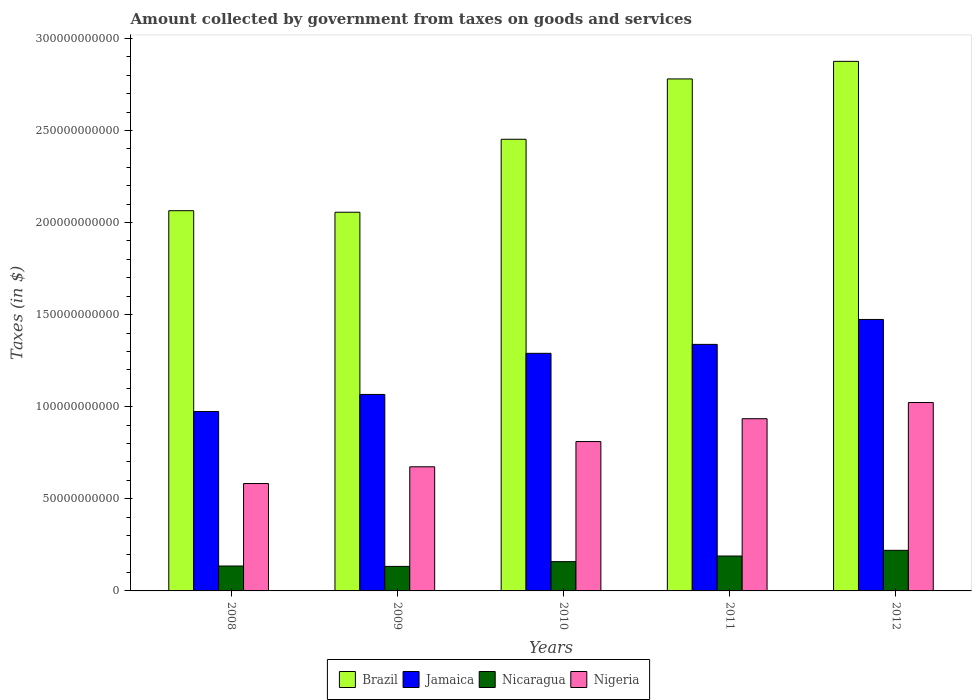How many different coloured bars are there?
Provide a short and direct response. 4. How many groups of bars are there?
Make the answer very short. 5. Are the number of bars per tick equal to the number of legend labels?
Ensure brevity in your answer.  Yes. Are the number of bars on each tick of the X-axis equal?
Ensure brevity in your answer.  Yes. How many bars are there on the 3rd tick from the right?
Offer a terse response. 4. What is the amount collected by government from taxes on goods and services in Nicaragua in 2012?
Your response must be concise. 2.20e+1. Across all years, what is the maximum amount collected by government from taxes on goods and services in Nicaragua?
Offer a terse response. 2.20e+1. Across all years, what is the minimum amount collected by government from taxes on goods and services in Nigeria?
Offer a very short reply. 5.83e+1. In which year was the amount collected by government from taxes on goods and services in Brazil maximum?
Offer a very short reply. 2012. In which year was the amount collected by government from taxes on goods and services in Nicaragua minimum?
Your response must be concise. 2009. What is the total amount collected by government from taxes on goods and services in Jamaica in the graph?
Your response must be concise. 6.14e+11. What is the difference between the amount collected by government from taxes on goods and services in Nicaragua in 2011 and that in 2012?
Keep it short and to the point. -3.09e+09. What is the difference between the amount collected by government from taxes on goods and services in Nigeria in 2011 and the amount collected by government from taxes on goods and services in Nicaragua in 2009?
Keep it short and to the point. 8.02e+1. What is the average amount collected by government from taxes on goods and services in Nicaragua per year?
Give a very brief answer. 1.67e+1. In the year 2008, what is the difference between the amount collected by government from taxes on goods and services in Nigeria and amount collected by government from taxes on goods and services in Brazil?
Keep it short and to the point. -1.48e+11. What is the ratio of the amount collected by government from taxes on goods and services in Nicaragua in 2008 to that in 2011?
Offer a terse response. 0.71. Is the amount collected by government from taxes on goods and services in Brazil in 2010 less than that in 2012?
Give a very brief answer. Yes. What is the difference between the highest and the second highest amount collected by government from taxes on goods and services in Brazil?
Provide a short and direct response. 9.55e+09. What is the difference between the highest and the lowest amount collected by government from taxes on goods and services in Nicaragua?
Provide a short and direct response. 8.72e+09. What does the 2nd bar from the left in 2012 represents?
Your response must be concise. Jamaica. What does the 3rd bar from the right in 2009 represents?
Offer a very short reply. Jamaica. Is it the case that in every year, the sum of the amount collected by government from taxes on goods and services in Jamaica and amount collected by government from taxes on goods and services in Brazil is greater than the amount collected by government from taxes on goods and services in Nigeria?
Your response must be concise. Yes. How many bars are there?
Keep it short and to the point. 20. Are all the bars in the graph horizontal?
Your response must be concise. No. How many years are there in the graph?
Provide a short and direct response. 5. Are the values on the major ticks of Y-axis written in scientific E-notation?
Your response must be concise. No. Does the graph contain grids?
Offer a terse response. No. How many legend labels are there?
Give a very brief answer. 4. What is the title of the graph?
Provide a succinct answer. Amount collected by government from taxes on goods and services. Does "Tonga" appear as one of the legend labels in the graph?
Offer a very short reply. No. What is the label or title of the X-axis?
Provide a short and direct response. Years. What is the label or title of the Y-axis?
Provide a succinct answer. Taxes (in $). What is the Taxes (in $) of Brazil in 2008?
Keep it short and to the point. 2.06e+11. What is the Taxes (in $) of Jamaica in 2008?
Your answer should be very brief. 9.74e+1. What is the Taxes (in $) in Nicaragua in 2008?
Offer a very short reply. 1.35e+1. What is the Taxes (in $) in Nigeria in 2008?
Offer a very short reply. 5.83e+1. What is the Taxes (in $) in Brazil in 2009?
Give a very brief answer. 2.06e+11. What is the Taxes (in $) of Jamaica in 2009?
Provide a short and direct response. 1.07e+11. What is the Taxes (in $) of Nicaragua in 2009?
Give a very brief answer. 1.33e+1. What is the Taxes (in $) in Nigeria in 2009?
Offer a very short reply. 6.74e+1. What is the Taxes (in $) in Brazil in 2010?
Your answer should be compact. 2.45e+11. What is the Taxes (in $) in Jamaica in 2010?
Ensure brevity in your answer.  1.29e+11. What is the Taxes (in $) of Nicaragua in 2010?
Offer a very short reply. 1.59e+1. What is the Taxes (in $) of Nigeria in 2010?
Your response must be concise. 8.11e+1. What is the Taxes (in $) of Brazil in 2011?
Offer a very short reply. 2.78e+11. What is the Taxes (in $) of Jamaica in 2011?
Your answer should be very brief. 1.34e+11. What is the Taxes (in $) in Nicaragua in 2011?
Make the answer very short. 1.89e+1. What is the Taxes (in $) of Nigeria in 2011?
Offer a very short reply. 9.35e+1. What is the Taxes (in $) in Brazil in 2012?
Offer a very short reply. 2.88e+11. What is the Taxes (in $) in Jamaica in 2012?
Offer a terse response. 1.47e+11. What is the Taxes (in $) of Nicaragua in 2012?
Ensure brevity in your answer.  2.20e+1. What is the Taxes (in $) of Nigeria in 2012?
Ensure brevity in your answer.  1.02e+11. Across all years, what is the maximum Taxes (in $) in Brazil?
Offer a very short reply. 2.88e+11. Across all years, what is the maximum Taxes (in $) in Jamaica?
Make the answer very short. 1.47e+11. Across all years, what is the maximum Taxes (in $) in Nicaragua?
Offer a very short reply. 2.20e+1. Across all years, what is the maximum Taxes (in $) of Nigeria?
Provide a succinct answer. 1.02e+11. Across all years, what is the minimum Taxes (in $) in Brazil?
Give a very brief answer. 2.06e+11. Across all years, what is the minimum Taxes (in $) of Jamaica?
Give a very brief answer. 9.74e+1. Across all years, what is the minimum Taxes (in $) in Nicaragua?
Your answer should be very brief. 1.33e+1. Across all years, what is the minimum Taxes (in $) of Nigeria?
Give a very brief answer. 5.83e+1. What is the total Taxes (in $) of Brazil in the graph?
Provide a short and direct response. 1.22e+12. What is the total Taxes (in $) of Jamaica in the graph?
Ensure brevity in your answer.  6.14e+11. What is the total Taxes (in $) in Nicaragua in the graph?
Ensure brevity in your answer.  8.37e+1. What is the total Taxes (in $) in Nigeria in the graph?
Provide a short and direct response. 4.03e+11. What is the difference between the Taxes (in $) of Brazil in 2008 and that in 2009?
Ensure brevity in your answer.  8.35e+08. What is the difference between the Taxes (in $) of Jamaica in 2008 and that in 2009?
Offer a terse response. -9.27e+09. What is the difference between the Taxes (in $) in Nicaragua in 2008 and that in 2009?
Give a very brief answer. 2.08e+08. What is the difference between the Taxes (in $) in Nigeria in 2008 and that in 2009?
Provide a short and direct response. -9.10e+09. What is the difference between the Taxes (in $) in Brazil in 2008 and that in 2010?
Make the answer very short. -3.88e+1. What is the difference between the Taxes (in $) in Jamaica in 2008 and that in 2010?
Offer a very short reply. -3.16e+1. What is the difference between the Taxes (in $) of Nicaragua in 2008 and that in 2010?
Ensure brevity in your answer.  -2.37e+09. What is the difference between the Taxes (in $) in Nigeria in 2008 and that in 2010?
Your response must be concise. -2.28e+1. What is the difference between the Taxes (in $) in Brazil in 2008 and that in 2011?
Offer a terse response. -7.15e+1. What is the difference between the Taxes (in $) in Jamaica in 2008 and that in 2011?
Offer a very short reply. -3.64e+1. What is the difference between the Taxes (in $) in Nicaragua in 2008 and that in 2011?
Offer a terse response. -5.42e+09. What is the difference between the Taxes (in $) in Nigeria in 2008 and that in 2011?
Provide a short and direct response. -3.52e+1. What is the difference between the Taxes (in $) in Brazil in 2008 and that in 2012?
Your response must be concise. -8.11e+1. What is the difference between the Taxes (in $) of Jamaica in 2008 and that in 2012?
Your response must be concise. -5.00e+1. What is the difference between the Taxes (in $) of Nicaragua in 2008 and that in 2012?
Offer a very short reply. -8.51e+09. What is the difference between the Taxes (in $) in Nigeria in 2008 and that in 2012?
Your answer should be very brief. -4.40e+1. What is the difference between the Taxes (in $) in Brazil in 2009 and that in 2010?
Provide a succinct answer. -3.96e+1. What is the difference between the Taxes (in $) in Jamaica in 2009 and that in 2010?
Ensure brevity in your answer.  -2.23e+1. What is the difference between the Taxes (in $) in Nicaragua in 2009 and that in 2010?
Give a very brief answer. -2.58e+09. What is the difference between the Taxes (in $) of Nigeria in 2009 and that in 2010?
Offer a terse response. -1.37e+1. What is the difference between the Taxes (in $) in Brazil in 2009 and that in 2011?
Your response must be concise. -7.24e+1. What is the difference between the Taxes (in $) in Jamaica in 2009 and that in 2011?
Your answer should be compact. -2.72e+1. What is the difference between the Taxes (in $) of Nicaragua in 2009 and that in 2011?
Your response must be concise. -5.63e+09. What is the difference between the Taxes (in $) in Nigeria in 2009 and that in 2011?
Keep it short and to the point. -2.61e+1. What is the difference between the Taxes (in $) in Brazil in 2009 and that in 2012?
Ensure brevity in your answer.  -8.19e+1. What is the difference between the Taxes (in $) of Jamaica in 2009 and that in 2012?
Keep it short and to the point. -4.07e+1. What is the difference between the Taxes (in $) of Nicaragua in 2009 and that in 2012?
Offer a very short reply. -8.72e+09. What is the difference between the Taxes (in $) in Nigeria in 2009 and that in 2012?
Offer a terse response. -3.49e+1. What is the difference between the Taxes (in $) in Brazil in 2010 and that in 2011?
Provide a short and direct response. -3.28e+1. What is the difference between the Taxes (in $) of Jamaica in 2010 and that in 2011?
Your response must be concise. -4.85e+09. What is the difference between the Taxes (in $) in Nicaragua in 2010 and that in 2011?
Provide a succinct answer. -3.05e+09. What is the difference between the Taxes (in $) in Nigeria in 2010 and that in 2011?
Provide a short and direct response. -1.24e+1. What is the difference between the Taxes (in $) of Brazil in 2010 and that in 2012?
Give a very brief answer. -4.23e+1. What is the difference between the Taxes (in $) in Jamaica in 2010 and that in 2012?
Offer a very short reply. -1.84e+1. What is the difference between the Taxes (in $) of Nicaragua in 2010 and that in 2012?
Ensure brevity in your answer.  -6.14e+09. What is the difference between the Taxes (in $) in Nigeria in 2010 and that in 2012?
Provide a succinct answer. -2.12e+1. What is the difference between the Taxes (in $) of Brazil in 2011 and that in 2012?
Your response must be concise. -9.55e+09. What is the difference between the Taxes (in $) in Jamaica in 2011 and that in 2012?
Give a very brief answer. -1.35e+1. What is the difference between the Taxes (in $) of Nicaragua in 2011 and that in 2012?
Give a very brief answer. -3.09e+09. What is the difference between the Taxes (in $) in Nigeria in 2011 and that in 2012?
Provide a short and direct response. -8.80e+09. What is the difference between the Taxes (in $) in Brazil in 2008 and the Taxes (in $) in Jamaica in 2009?
Make the answer very short. 9.98e+1. What is the difference between the Taxes (in $) of Brazil in 2008 and the Taxes (in $) of Nicaragua in 2009?
Give a very brief answer. 1.93e+11. What is the difference between the Taxes (in $) in Brazil in 2008 and the Taxes (in $) in Nigeria in 2009?
Offer a very short reply. 1.39e+11. What is the difference between the Taxes (in $) in Jamaica in 2008 and the Taxes (in $) in Nicaragua in 2009?
Ensure brevity in your answer.  8.41e+1. What is the difference between the Taxes (in $) of Jamaica in 2008 and the Taxes (in $) of Nigeria in 2009?
Offer a terse response. 3.00e+1. What is the difference between the Taxes (in $) in Nicaragua in 2008 and the Taxes (in $) in Nigeria in 2009?
Provide a succinct answer. -5.39e+1. What is the difference between the Taxes (in $) in Brazil in 2008 and the Taxes (in $) in Jamaica in 2010?
Offer a terse response. 7.74e+1. What is the difference between the Taxes (in $) of Brazil in 2008 and the Taxes (in $) of Nicaragua in 2010?
Make the answer very short. 1.91e+11. What is the difference between the Taxes (in $) in Brazil in 2008 and the Taxes (in $) in Nigeria in 2010?
Offer a very short reply. 1.25e+11. What is the difference between the Taxes (in $) in Jamaica in 2008 and the Taxes (in $) in Nicaragua in 2010?
Your answer should be compact. 8.15e+1. What is the difference between the Taxes (in $) of Jamaica in 2008 and the Taxes (in $) of Nigeria in 2010?
Provide a succinct answer. 1.63e+1. What is the difference between the Taxes (in $) of Nicaragua in 2008 and the Taxes (in $) of Nigeria in 2010?
Your answer should be compact. -6.76e+1. What is the difference between the Taxes (in $) of Brazil in 2008 and the Taxes (in $) of Jamaica in 2011?
Your answer should be very brief. 7.26e+1. What is the difference between the Taxes (in $) in Brazil in 2008 and the Taxes (in $) in Nicaragua in 2011?
Provide a succinct answer. 1.87e+11. What is the difference between the Taxes (in $) in Brazil in 2008 and the Taxes (in $) in Nigeria in 2011?
Provide a succinct answer. 1.13e+11. What is the difference between the Taxes (in $) of Jamaica in 2008 and the Taxes (in $) of Nicaragua in 2011?
Your answer should be very brief. 7.85e+1. What is the difference between the Taxes (in $) of Jamaica in 2008 and the Taxes (in $) of Nigeria in 2011?
Your answer should be very brief. 3.91e+09. What is the difference between the Taxes (in $) of Nicaragua in 2008 and the Taxes (in $) of Nigeria in 2011?
Keep it short and to the point. -8.00e+1. What is the difference between the Taxes (in $) of Brazil in 2008 and the Taxes (in $) of Jamaica in 2012?
Provide a succinct answer. 5.91e+1. What is the difference between the Taxes (in $) of Brazil in 2008 and the Taxes (in $) of Nicaragua in 2012?
Provide a succinct answer. 1.84e+11. What is the difference between the Taxes (in $) in Brazil in 2008 and the Taxes (in $) in Nigeria in 2012?
Make the answer very short. 1.04e+11. What is the difference between the Taxes (in $) of Jamaica in 2008 and the Taxes (in $) of Nicaragua in 2012?
Your response must be concise. 7.54e+1. What is the difference between the Taxes (in $) in Jamaica in 2008 and the Taxes (in $) in Nigeria in 2012?
Offer a terse response. -4.89e+09. What is the difference between the Taxes (in $) in Nicaragua in 2008 and the Taxes (in $) in Nigeria in 2012?
Provide a succinct answer. -8.88e+1. What is the difference between the Taxes (in $) in Brazil in 2009 and the Taxes (in $) in Jamaica in 2010?
Provide a succinct answer. 7.66e+1. What is the difference between the Taxes (in $) of Brazil in 2009 and the Taxes (in $) of Nicaragua in 2010?
Offer a very short reply. 1.90e+11. What is the difference between the Taxes (in $) of Brazil in 2009 and the Taxes (in $) of Nigeria in 2010?
Give a very brief answer. 1.25e+11. What is the difference between the Taxes (in $) of Jamaica in 2009 and the Taxes (in $) of Nicaragua in 2010?
Provide a short and direct response. 9.08e+1. What is the difference between the Taxes (in $) of Jamaica in 2009 and the Taxes (in $) of Nigeria in 2010?
Provide a succinct answer. 2.56e+1. What is the difference between the Taxes (in $) in Nicaragua in 2009 and the Taxes (in $) in Nigeria in 2010?
Give a very brief answer. -6.78e+1. What is the difference between the Taxes (in $) in Brazil in 2009 and the Taxes (in $) in Jamaica in 2011?
Your answer should be very brief. 7.17e+1. What is the difference between the Taxes (in $) of Brazil in 2009 and the Taxes (in $) of Nicaragua in 2011?
Offer a terse response. 1.87e+11. What is the difference between the Taxes (in $) in Brazil in 2009 and the Taxes (in $) in Nigeria in 2011?
Your answer should be very brief. 1.12e+11. What is the difference between the Taxes (in $) in Jamaica in 2009 and the Taxes (in $) in Nicaragua in 2011?
Make the answer very short. 8.77e+1. What is the difference between the Taxes (in $) in Jamaica in 2009 and the Taxes (in $) in Nigeria in 2011?
Offer a terse response. 1.32e+1. What is the difference between the Taxes (in $) in Nicaragua in 2009 and the Taxes (in $) in Nigeria in 2011?
Your answer should be compact. -8.02e+1. What is the difference between the Taxes (in $) of Brazil in 2009 and the Taxes (in $) of Jamaica in 2012?
Ensure brevity in your answer.  5.82e+1. What is the difference between the Taxes (in $) of Brazil in 2009 and the Taxes (in $) of Nicaragua in 2012?
Provide a short and direct response. 1.84e+11. What is the difference between the Taxes (in $) in Brazil in 2009 and the Taxes (in $) in Nigeria in 2012?
Give a very brief answer. 1.03e+11. What is the difference between the Taxes (in $) of Jamaica in 2009 and the Taxes (in $) of Nicaragua in 2012?
Your answer should be compact. 8.46e+1. What is the difference between the Taxes (in $) in Jamaica in 2009 and the Taxes (in $) in Nigeria in 2012?
Keep it short and to the point. 4.38e+09. What is the difference between the Taxes (in $) in Nicaragua in 2009 and the Taxes (in $) in Nigeria in 2012?
Give a very brief answer. -8.90e+1. What is the difference between the Taxes (in $) of Brazil in 2010 and the Taxes (in $) of Jamaica in 2011?
Make the answer very short. 1.11e+11. What is the difference between the Taxes (in $) in Brazil in 2010 and the Taxes (in $) in Nicaragua in 2011?
Provide a succinct answer. 2.26e+11. What is the difference between the Taxes (in $) of Brazil in 2010 and the Taxes (in $) of Nigeria in 2011?
Your answer should be very brief. 1.52e+11. What is the difference between the Taxes (in $) in Jamaica in 2010 and the Taxes (in $) in Nicaragua in 2011?
Make the answer very short. 1.10e+11. What is the difference between the Taxes (in $) of Jamaica in 2010 and the Taxes (in $) of Nigeria in 2011?
Provide a short and direct response. 3.55e+1. What is the difference between the Taxes (in $) of Nicaragua in 2010 and the Taxes (in $) of Nigeria in 2011?
Make the answer very short. -7.76e+1. What is the difference between the Taxes (in $) in Brazil in 2010 and the Taxes (in $) in Jamaica in 2012?
Your answer should be very brief. 9.78e+1. What is the difference between the Taxes (in $) of Brazil in 2010 and the Taxes (in $) of Nicaragua in 2012?
Your response must be concise. 2.23e+11. What is the difference between the Taxes (in $) of Brazil in 2010 and the Taxes (in $) of Nigeria in 2012?
Offer a terse response. 1.43e+11. What is the difference between the Taxes (in $) in Jamaica in 2010 and the Taxes (in $) in Nicaragua in 2012?
Provide a succinct answer. 1.07e+11. What is the difference between the Taxes (in $) of Jamaica in 2010 and the Taxes (in $) of Nigeria in 2012?
Offer a terse response. 2.67e+1. What is the difference between the Taxes (in $) in Nicaragua in 2010 and the Taxes (in $) in Nigeria in 2012?
Give a very brief answer. -8.64e+1. What is the difference between the Taxes (in $) of Brazil in 2011 and the Taxes (in $) of Jamaica in 2012?
Your response must be concise. 1.31e+11. What is the difference between the Taxes (in $) in Brazil in 2011 and the Taxes (in $) in Nicaragua in 2012?
Your answer should be very brief. 2.56e+11. What is the difference between the Taxes (in $) of Brazil in 2011 and the Taxes (in $) of Nigeria in 2012?
Offer a very short reply. 1.76e+11. What is the difference between the Taxes (in $) of Jamaica in 2011 and the Taxes (in $) of Nicaragua in 2012?
Offer a terse response. 1.12e+11. What is the difference between the Taxes (in $) of Jamaica in 2011 and the Taxes (in $) of Nigeria in 2012?
Make the answer very short. 3.16e+1. What is the difference between the Taxes (in $) in Nicaragua in 2011 and the Taxes (in $) in Nigeria in 2012?
Ensure brevity in your answer.  -8.34e+1. What is the average Taxes (in $) in Brazil per year?
Offer a terse response. 2.45e+11. What is the average Taxes (in $) in Jamaica per year?
Your answer should be compact. 1.23e+11. What is the average Taxes (in $) in Nicaragua per year?
Offer a terse response. 1.67e+1. What is the average Taxes (in $) in Nigeria per year?
Make the answer very short. 8.05e+1. In the year 2008, what is the difference between the Taxes (in $) in Brazil and Taxes (in $) in Jamaica?
Your answer should be very brief. 1.09e+11. In the year 2008, what is the difference between the Taxes (in $) of Brazil and Taxes (in $) of Nicaragua?
Give a very brief answer. 1.93e+11. In the year 2008, what is the difference between the Taxes (in $) of Brazil and Taxes (in $) of Nigeria?
Offer a very short reply. 1.48e+11. In the year 2008, what is the difference between the Taxes (in $) in Jamaica and Taxes (in $) in Nicaragua?
Give a very brief answer. 8.39e+1. In the year 2008, what is the difference between the Taxes (in $) of Jamaica and Taxes (in $) of Nigeria?
Offer a terse response. 3.91e+1. In the year 2008, what is the difference between the Taxes (in $) of Nicaragua and Taxes (in $) of Nigeria?
Give a very brief answer. -4.48e+1. In the year 2009, what is the difference between the Taxes (in $) of Brazil and Taxes (in $) of Jamaica?
Provide a succinct answer. 9.89e+1. In the year 2009, what is the difference between the Taxes (in $) of Brazil and Taxes (in $) of Nicaragua?
Provide a short and direct response. 1.92e+11. In the year 2009, what is the difference between the Taxes (in $) in Brazil and Taxes (in $) in Nigeria?
Provide a succinct answer. 1.38e+11. In the year 2009, what is the difference between the Taxes (in $) of Jamaica and Taxes (in $) of Nicaragua?
Provide a short and direct response. 9.34e+1. In the year 2009, what is the difference between the Taxes (in $) in Jamaica and Taxes (in $) in Nigeria?
Your answer should be very brief. 3.93e+1. In the year 2009, what is the difference between the Taxes (in $) of Nicaragua and Taxes (in $) of Nigeria?
Offer a very short reply. -5.41e+1. In the year 2010, what is the difference between the Taxes (in $) in Brazil and Taxes (in $) in Jamaica?
Your response must be concise. 1.16e+11. In the year 2010, what is the difference between the Taxes (in $) in Brazil and Taxes (in $) in Nicaragua?
Provide a succinct answer. 2.29e+11. In the year 2010, what is the difference between the Taxes (in $) of Brazil and Taxes (in $) of Nigeria?
Offer a very short reply. 1.64e+11. In the year 2010, what is the difference between the Taxes (in $) of Jamaica and Taxes (in $) of Nicaragua?
Keep it short and to the point. 1.13e+11. In the year 2010, what is the difference between the Taxes (in $) of Jamaica and Taxes (in $) of Nigeria?
Offer a terse response. 4.79e+1. In the year 2010, what is the difference between the Taxes (in $) in Nicaragua and Taxes (in $) in Nigeria?
Provide a short and direct response. -6.52e+1. In the year 2011, what is the difference between the Taxes (in $) of Brazil and Taxes (in $) of Jamaica?
Offer a terse response. 1.44e+11. In the year 2011, what is the difference between the Taxes (in $) in Brazil and Taxes (in $) in Nicaragua?
Your answer should be compact. 2.59e+11. In the year 2011, what is the difference between the Taxes (in $) of Brazil and Taxes (in $) of Nigeria?
Your answer should be very brief. 1.84e+11. In the year 2011, what is the difference between the Taxes (in $) in Jamaica and Taxes (in $) in Nicaragua?
Your answer should be very brief. 1.15e+11. In the year 2011, what is the difference between the Taxes (in $) of Jamaica and Taxes (in $) of Nigeria?
Keep it short and to the point. 4.04e+1. In the year 2011, what is the difference between the Taxes (in $) in Nicaragua and Taxes (in $) in Nigeria?
Your response must be concise. -7.46e+1. In the year 2012, what is the difference between the Taxes (in $) of Brazil and Taxes (in $) of Jamaica?
Give a very brief answer. 1.40e+11. In the year 2012, what is the difference between the Taxes (in $) in Brazil and Taxes (in $) in Nicaragua?
Your response must be concise. 2.65e+11. In the year 2012, what is the difference between the Taxes (in $) in Brazil and Taxes (in $) in Nigeria?
Provide a short and direct response. 1.85e+11. In the year 2012, what is the difference between the Taxes (in $) in Jamaica and Taxes (in $) in Nicaragua?
Your response must be concise. 1.25e+11. In the year 2012, what is the difference between the Taxes (in $) in Jamaica and Taxes (in $) in Nigeria?
Offer a terse response. 4.51e+1. In the year 2012, what is the difference between the Taxes (in $) in Nicaragua and Taxes (in $) in Nigeria?
Make the answer very short. -8.03e+1. What is the ratio of the Taxes (in $) in Brazil in 2008 to that in 2009?
Ensure brevity in your answer.  1. What is the ratio of the Taxes (in $) in Jamaica in 2008 to that in 2009?
Offer a terse response. 0.91. What is the ratio of the Taxes (in $) of Nicaragua in 2008 to that in 2009?
Your answer should be compact. 1.02. What is the ratio of the Taxes (in $) of Nigeria in 2008 to that in 2009?
Offer a terse response. 0.86. What is the ratio of the Taxes (in $) of Brazil in 2008 to that in 2010?
Ensure brevity in your answer.  0.84. What is the ratio of the Taxes (in $) in Jamaica in 2008 to that in 2010?
Keep it short and to the point. 0.76. What is the ratio of the Taxes (in $) in Nicaragua in 2008 to that in 2010?
Your answer should be very brief. 0.85. What is the ratio of the Taxes (in $) of Nigeria in 2008 to that in 2010?
Make the answer very short. 0.72. What is the ratio of the Taxes (in $) in Brazil in 2008 to that in 2011?
Offer a very short reply. 0.74. What is the ratio of the Taxes (in $) of Jamaica in 2008 to that in 2011?
Keep it short and to the point. 0.73. What is the ratio of the Taxes (in $) of Nicaragua in 2008 to that in 2011?
Make the answer very short. 0.71. What is the ratio of the Taxes (in $) of Nigeria in 2008 to that in 2011?
Offer a very short reply. 0.62. What is the ratio of the Taxes (in $) in Brazil in 2008 to that in 2012?
Ensure brevity in your answer.  0.72. What is the ratio of the Taxes (in $) in Jamaica in 2008 to that in 2012?
Offer a terse response. 0.66. What is the ratio of the Taxes (in $) of Nicaragua in 2008 to that in 2012?
Offer a terse response. 0.61. What is the ratio of the Taxes (in $) in Nigeria in 2008 to that in 2012?
Your answer should be very brief. 0.57. What is the ratio of the Taxes (in $) in Brazil in 2009 to that in 2010?
Make the answer very short. 0.84. What is the ratio of the Taxes (in $) in Jamaica in 2009 to that in 2010?
Your response must be concise. 0.83. What is the ratio of the Taxes (in $) in Nicaragua in 2009 to that in 2010?
Offer a very short reply. 0.84. What is the ratio of the Taxes (in $) of Nigeria in 2009 to that in 2010?
Offer a terse response. 0.83. What is the ratio of the Taxes (in $) in Brazil in 2009 to that in 2011?
Your answer should be compact. 0.74. What is the ratio of the Taxes (in $) in Jamaica in 2009 to that in 2011?
Your answer should be compact. 0.8. What is the ratio of the Taxes (in $) of Nicaragua in 2009 to that in 2011?
Your answer should be very brief. 0.7. What is the ratio of the Taxes (in $) in Nigeria in 2009 to that in 2011?
Your response must be concise. 0.72. What is the ratio of the Taxes (in $) in Brazil in 2009 to that in 2012?
Make the answer very short. 0.72. What is the ratio of the Taxes (in $) in Jamaica in 2009 to that in 2012?
Provide a succinct answer. 0.72. What is the ratio of the Taxes (in $) in Nicaragua in 2009 to that in 2012?
Keep it short and to the point. 0.6. What is the ratio of the Taxes (in $) of Nigeria in 2009 to that in 2012?
Provide a succinct answer. 0.66. What is the ratio of the Taxes (in $) of Brazil in 2010 to that in 2011?
Offer a very short reply. 0.88. What is the ratio of the Taxes (in $) of Jamaica in 2010 to that in 2011?
Offer a very short reply. 0.96. What is the ratio of the Taxes (in $) of Nicaragua in 2010 to that in 2011?
Offer a very short reply. 0.84. What is the ratio of the Taxes (in $) in Nigeria in 2010 to that in 2011?
Your answer should be very brief. 0.87. What is the ratio of the Taxes (in $) of Brazil in 2010 to that in 2012?
Keep it short and to the point. 0.85. What is the ratio of the Taxes (in $) of Jamaica in 2010 to that in 2012?
Ensure brevity in your answer.  0.88. What is the ratio of the Taxes (in $) in Nicaragua in 2010 to that in 2012?
Offer a terse response. 0.72. What is the ratio of the Taxes (in $) of Nigeria in 2010 to that in 2012?
Make the answer very short. 0.79. What is the ratio of the Taxes (in $) of Brazil in 2011 to that in 2012?
Provide a short and direct response. 0.97. What is the ratio of the Taxes (in $) of Jamaica in 2011 to that in 2012?
Offer a terse response. 0.91. What is the ratio of the Taxes (in $) in Nicaragua in 2011 to that in 2012?
Ensure brevity in your answer.  0.86. What is the ratio of the Taxes (in $) of Nigeria in 2011 to that in 2012?
Offer a very short reply. 0.91. What is the difference between the highest and the second highest Taxes (in $) of Brazil?
Ensure brevity in your answer.  9.55e+09. What is the difference between the highest and the second highest Taxes (in $) in Jamaica?
Make the answer very short. 1.35e+1. What is the difference between the highest and the second highest Taxes (in $) of Nicaragua?
Your response must be concise. 3.09e+09. What is the difference between the highest and the second highest Taxes (in $) in Nigeria?
Keep it short and to the point. 8.80e+09. What is the difference between the highest and the lowest Taxes (in $) in Brazil?
Keep it short and to the point. 8.19e+1. What is the difference between the highest and the lowest Taxes (in $) in Jamaica?
Keep it short and to the point. 5.00e+1. What is the difference between the highest and the lowest Taxes (in $) in Nicaragua?
Your answer should be very brief. 8.72e+09. What is the difference between the highest and the lowest Taxes (in $) in Nigeria?
Keep it short and to the point. 4.40e+1. 